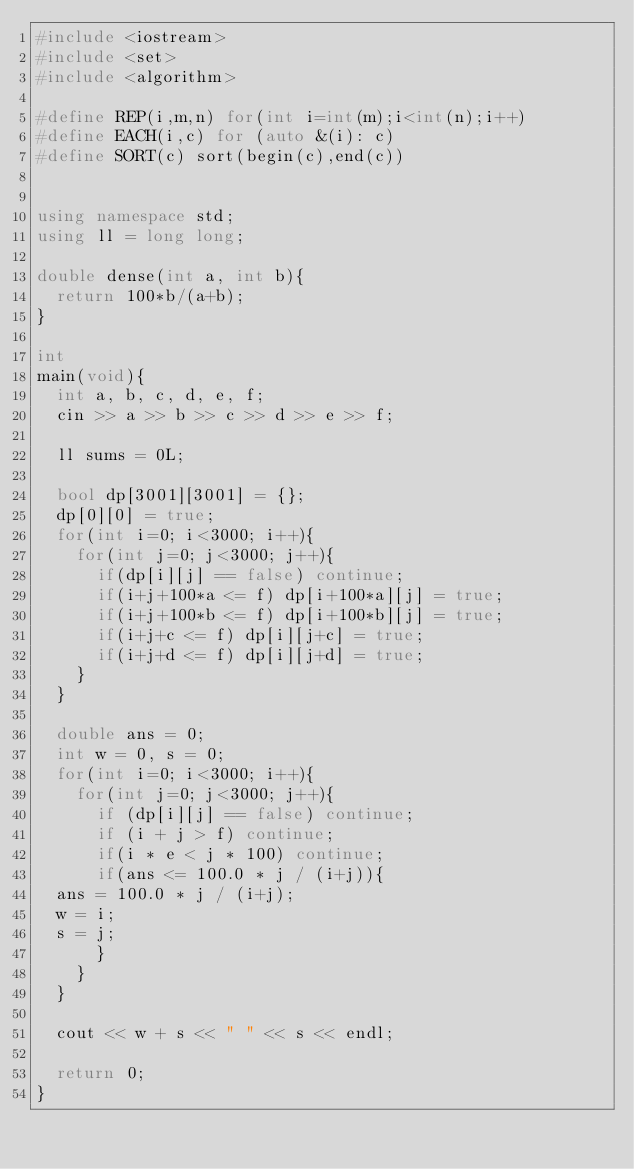<code> <loc_0><loc_0><loc_500><loc_500><_C++_>#include <iostream>
#include <set>
#include <algorithm>

#define REP(i,m,n) for(int i=int(m);i<int(n);i++)
#define EACH(i,c) for (auto &(i): c)
#define SORT(c) sort(begin(c),end(c))


using namespace std;
using ll = long long;

double dense(int a, int b){
  return 100*b/(a+b);
}

int
main(void){
  int a, b, c, d, e, f;
  cin >> a >> b >> c >> d >> e >> f;

  ll sums = 0L;

  bool dp[3001][3001] = {};
  dp[0][0] = true;
  for(int i=0; i<3000; i++){
    for(int j=0; j<3000; j++){
      if(dp[i][j] == false) continue;
      if(i+j+100*a <= f) dp[i+100*a][j] = true;
      if(i+j+100*b <= f) dp[i+100*b][j] = true;
      if(i+j+c <= f) dp[i][j+c] = true;
      if(i+j+d <= f) dp[i][j+d] = true;
    }
  }

  double ans = 0;
  int w = 0, s = 0;
  for(int i=0; i<3000; i++){
    for(int j=0; j<3000; j++){  
      if (dp[i][j] == false) continue;
      if (i + j > f) continue;
      if(i * e < j * 100) continue;
      if(ans <= 100.0 * j / (i+j)){
	ans = 100.0 * j / (i+j);
	w = i;
	s = j;
      }
    }
  }

  cout << w + s << " " << s << endl;
  
  return 0;
}
</code> 